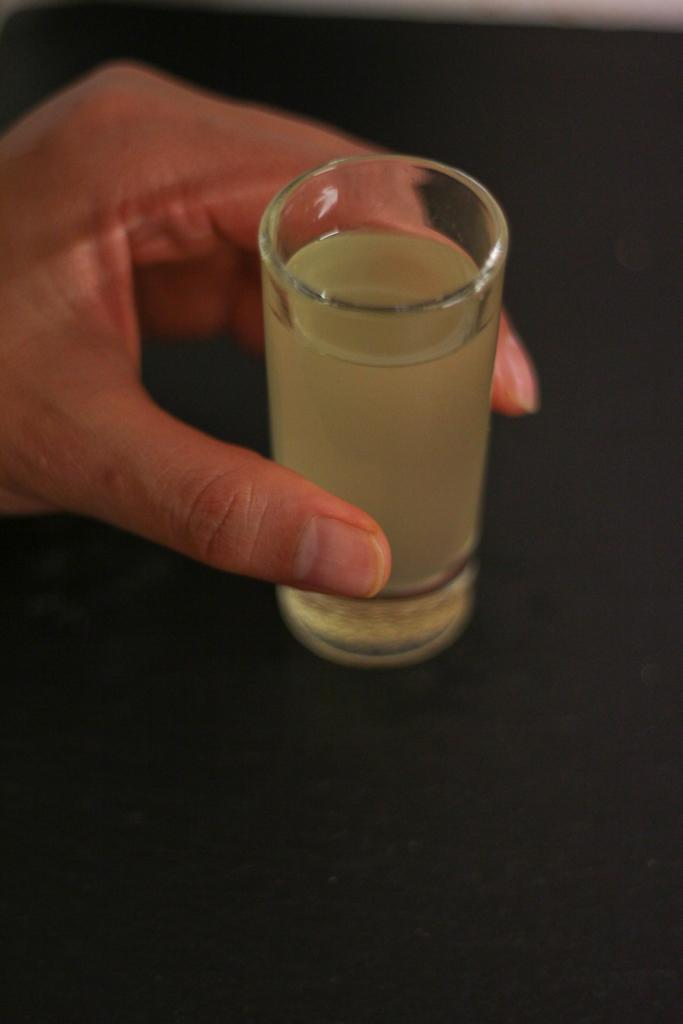What is the person in the image holding? The person is holding a glass. What is inside the glass that the person is holding? The glass contains a drink. What is the color of the surface beneath the glass? The surface beneath the glass is black. How many grapes are visible on the person's account in the image? There are no grapes or accounts present in the image. What type of flowers can be seen growing on the person's head in the image? There are no flowers or any indication of a head in the image. 